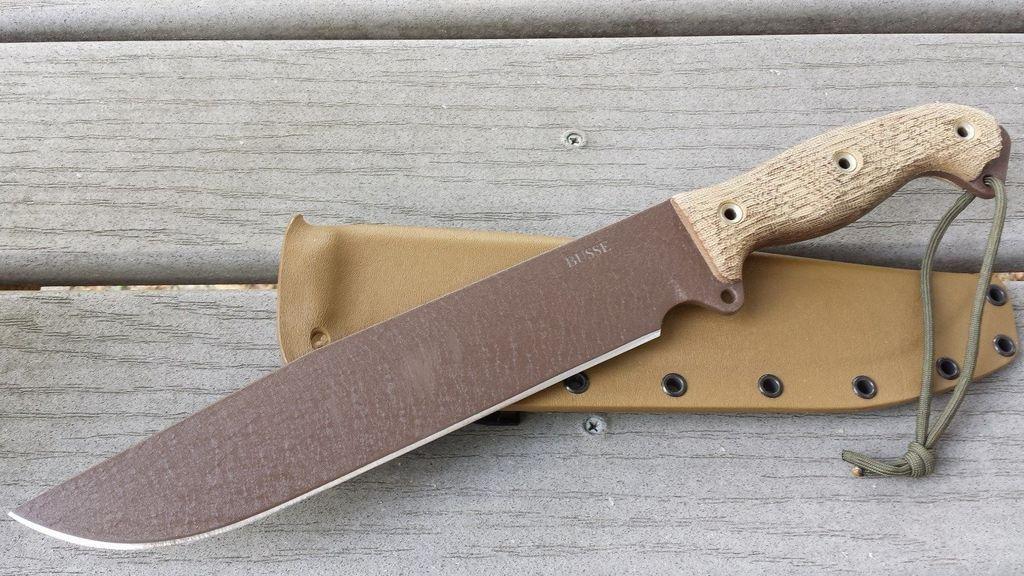Please provide a concise description of this image. In the image there is a knife kept on the knife cover on a wooden surface. 